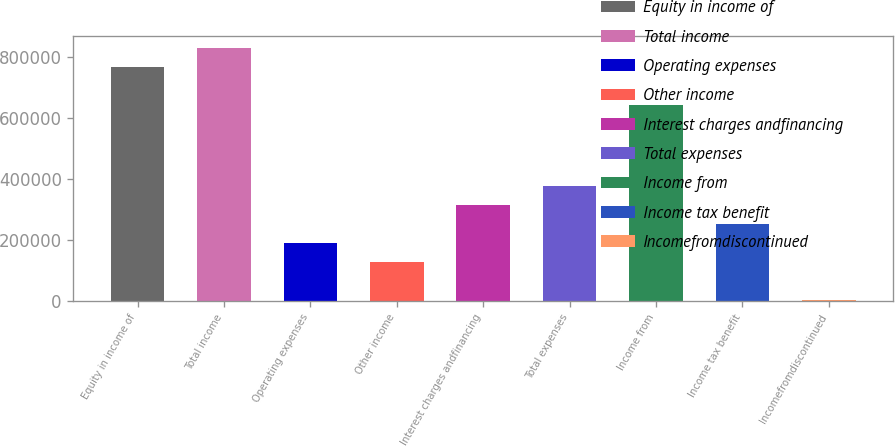Convert chart. <chart><loc_0><loc_0><loc_500><loc_500><bar_chart><fcel>Equity in income of<fcel>Total income<fcel>Operating expenses<fcel>Other income<fcel>Interest charges andfinancing<fcel>Total expenses<fcel>Income from<fcel>Income tax benefit<fcel>Incomefromdiscontinued<nl><fcel>766247<fcel>828470<fcel>189740<fcel>127518<fcel>314186<fcel>376408<fcel>641802<fcel>251963<fcel>3073<nl></chart> 